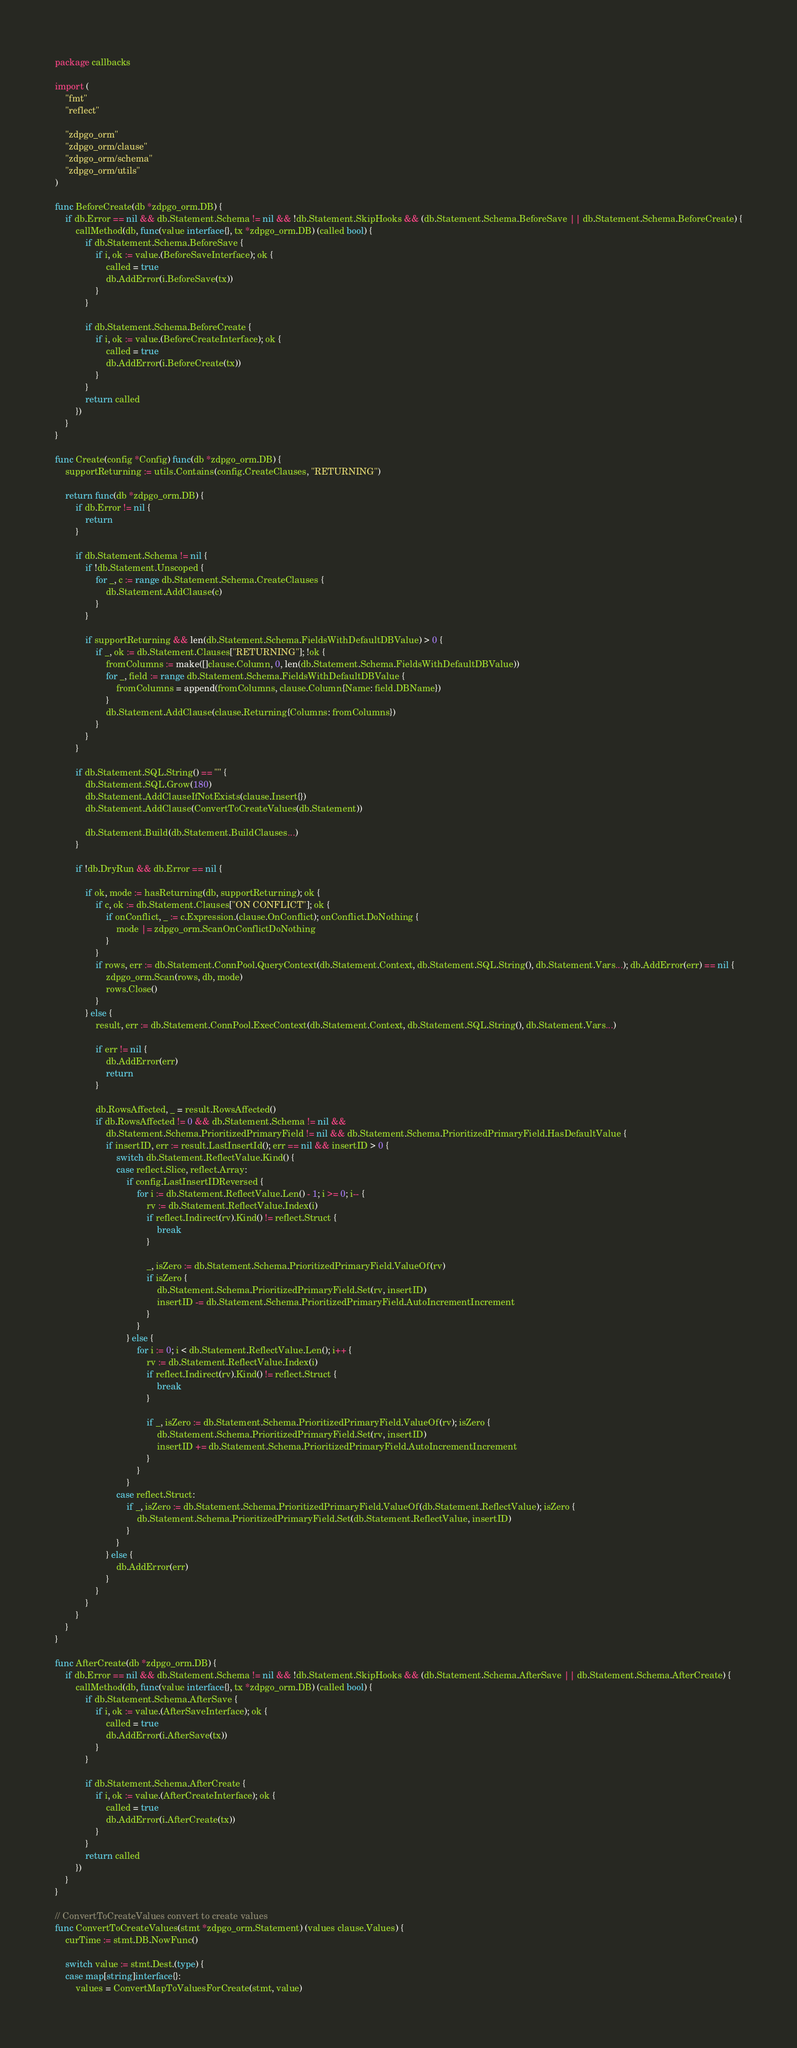Convert code to text. <code><loc_0><loc_0><loc_500><loc_500><_Go_>package callbacks

import (
	"fmt"
	"reflect"

	"zdpgo_orm"
	"zdpgo_orm/clause"
	"zdpgo_orm/schema"
	"zdpgo_orm/utils"
)

func BeforeCreate(db *zdpgo_orm.DB) {
	if db.Error == nil && db.Statement.Schema != nil && !db.Statement.SkipHooks && (db.Statement.Schema.BeforeSave || db.Statement.Schema.BeforeCreate) {
		callMethod(db, func(value interface{}, tx *zdpgo_orm.DB) (called bool) {
			if db.Statement.Schema.BeforeSave {
				if i, ok := value.(BeforeSaveInterface); ok {
					called = true
					db.AddError(i.BeforeSave(tx))
				}
			}

			if db.Statement.Schema.BeforeCreate {
				if i, ok := value.(BeforeCreateInterface); ok {
					called = true
					db.AddError(i.BeforeCreate(tx))
				}
			}
			return called
		})
	}
}

func Create(config *Config) func(db *zdpgo_orm.DB) {
	supportReturning := utils.Contains(config.CreateClauses, "RETURNING")

	return func(db *zdpgo_orm.DB) {
		if db.Error != nil {
			return
		}

		if db.Statement.Schema != nil {
			if !db.Statement.Unscoped {
				for _, c := range db.Statement.Schema.CreateClauses {
					db.Statement.AddClause(c)
				}
			}

			if supportReturning && len(db.Statement.Schema.FieldsWithDefaultDBValue) > 0 {
				if _, ok := db.Statement.Clauses["RETURNING"]; !ok {
					fromColumns := make([]clause.Column, 0, len(db.Statement.Schema.FieldsWithDefaultDBValue))
					for _, field := range db.Statement.Schema.FieldsWithDefaultDBValue {
						fromColumns = append(fromColumns, clause.Column{Name: field.DBName})
					}
					db.Statement.AddClause(clause.Returning{Columns: fromColumns})
				}
			}
		}

		if db.Statement.SQL.String() == "" {
			db.Statement.SQL.Grow(180)
			db.Statement.AddClauseIfNotExists(clause.Insert{})
			db.Statement.AddClause(ConvertToCreateValues(db.Statement))

			db.Statement.Build(db.Statement.BuildClauses...)
		}

		if !db.DryRun && db.Error == nil {

			if ok, mode := hasReturning(db, supportReturning); ok {
				if c, ok := db.Statement.Clauses["ON CONFLICT"]; ok {
					if onConflict, _ := c.Expression.(clause.OnConflict); onConflict.DoNothing {
						mode |= zdpgo_orm.ScanOnConflictDoNothing
					}
				}
				if rows, err := db.Statement.ConnPool.QueryContext(db.Statement.Context, db.Statement.SQL.String(), db.Statement.Vars...); db.AddError(err) == nil {
					zdpgo_orm.Scan(rows, db, mode)
					rows.Close()
				}
			} else {
				result, err := db.Statement.ConnPool.ExecContext(db.Statement.Context, db.Statement.SQL.String(), db.Statement.Vars...)

				if err != nil {
					db.AddError(err)
					return
				}

				db.RowsAffected, _ = result.RowsAffected()
				if db.RowsAffected != 0 && db.Statement.Schema != nil &&
					db.Statement.Schema.PrioritizedPrimaryField != nil && db.Statement.Schema.PrioritizedPrimaryField.HasDefaultValue {
					if insertID, err := result.LastInsertId(); err == nil && insertID > 0 {
						switch db.Statement.ReflectValue.Kind() {
						case reflect.Slice, reflect.Array:
							if config.LastInsertIDReversed {
								for i := db.Statement.ReflectValue.Len() - 1; i >= 0; i-- {
									rv := db.Statement.ReflectValue.Index(i)
									if reflect.Indirect(rv).Kind() != reflect.Struct {
										break
									}

									_, isZero := db.Statement.Schema.PrioritizedPrimaryField.ValueOf(rv)
									if isZero {
										db.Statement.Schema.PrioritizedPrimaryField.Set(rv, insertID)
										insertID -= db.Statement.Schema.PrioritizedPrimaryField.AutoIncrementIncrement
									}
								}
							} else {
								for i := 0; i < db.Statement.ReflectValue.Len(); i++ {
									rv := db.Statement.ReflectValue.Index(i)
									if reflect.Indirect(rv).Kind() != reflect.Struct {
										break
									}

									if _, isZero := db.Statement.Schema.PrioritizedPrimaryField.ValueOf(rv); isZero {
										db.Statement.Schema.PrioritizedPrimaryField.Set(rv, insertID)
										insertID += db.Statement.Schema.PrioritizedPrimaryField.AutoIncrementIncrement
									}
								}
							}
						case reflect.Struct:
							if _, isZero := db.Statement.Schema.PrioritizedPrimaryField.ValueOf(db.Statement.ReflectValue); isZero {
								db.Statement.Schema.PrioritizedPrimaryField.Set(db.Statement.ReflectValue, insertID)
							}
						}
					} else {
						db.AddError(err)
					}
				}
			}
		}
	}
}

func AfterCreate(db *zdpgo_orm.DB) {
	if db.Error == nil && db.Statement.Schema != nil && !db.Statement.SkipHooks && (db.Statement.Schema.AfterSave || db.Statement.Schema.AfterCreate) {
		callMethod(db, func(value interface{}, tx *zdpgo_orm.DB) (called bool) {
			if db.Statement.Schema.AfterSave {
				if i, ok := value.(AfterSaveInterface); ok {
					called = true
					db.AddError(i.AfterSave(tx))
				}
			}

			if db.Statement.Schema.AfterCreate {
				if i, ok := value.(AfterCreateInterface); ok {
					called = true
					db.AddError(i.AfterCreate(tx))
				}
			}
			return called
		})
	}
}

// ConvertToCreateValues convert to create values
func ConvertToCreateValues(stmt *zdpgo_orm.Statement) (values clause.Values) {
	curTime := stmt.DB.NowFunc()

	switch value := stmt.Dest.(type) {
	case map[string]interface{}:
		values = ConvertMapToValuesForCreate(stmt, value)</code> 